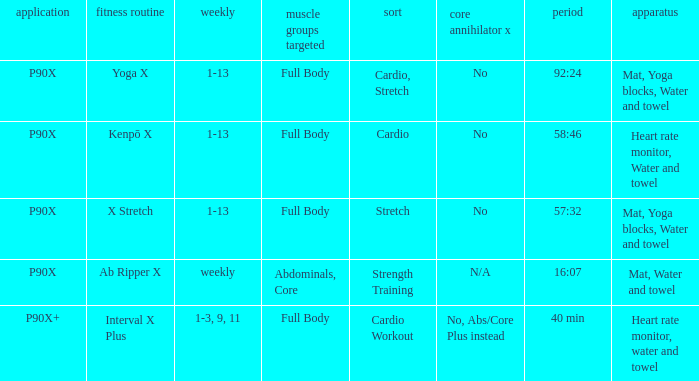What is the exercise when the equipment is heart rate monitor, water and towel? Kenpō X, Interval X Plus. 